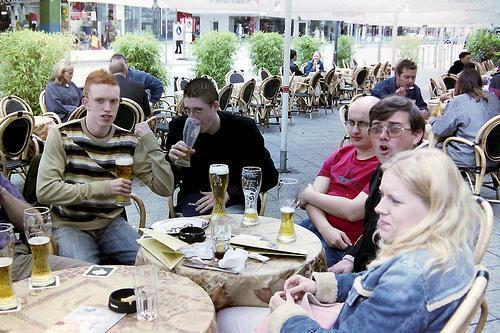How many ashtrays are visible?
Give a very brief answer. 2. How many men are wearing a red shirt?
Give a very brief answer. 1. How many men have red hair?
Give a very brief answer. 1. How many people are looking at the camera?
Give a very brief answer. 1. How many men are holding a glass of beer?
Give a very brief answer. 2. How many people are wearing glasses?
Give a very brief answer. 1. 